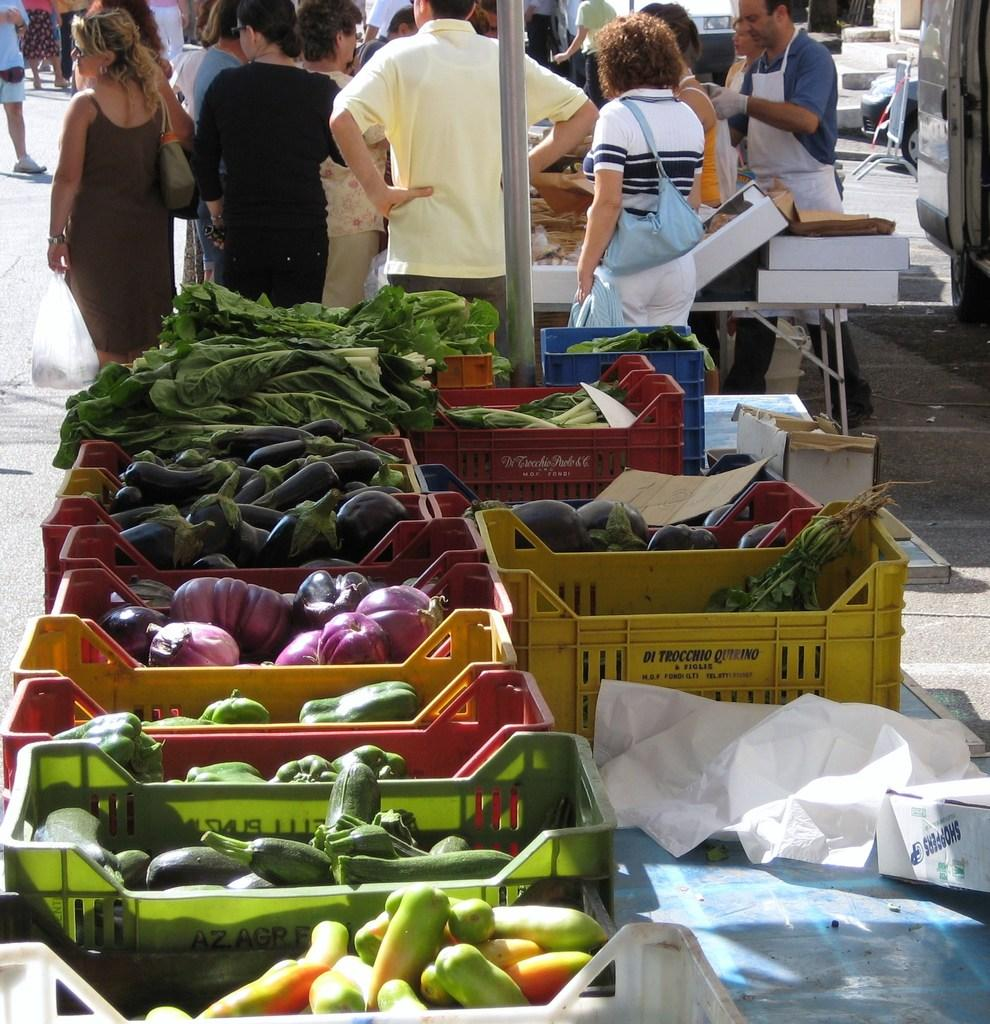What type of food items can be seen in the image? There are vegetables in trays at the bottom of the image. Can you describe the people in the image? A group of people are standing at the top of the image. What might be the setting of the image? The image appears to depict a market setting. What type of rod is being used for fishing in the image? There is no rod or fishing activity present in the image. 